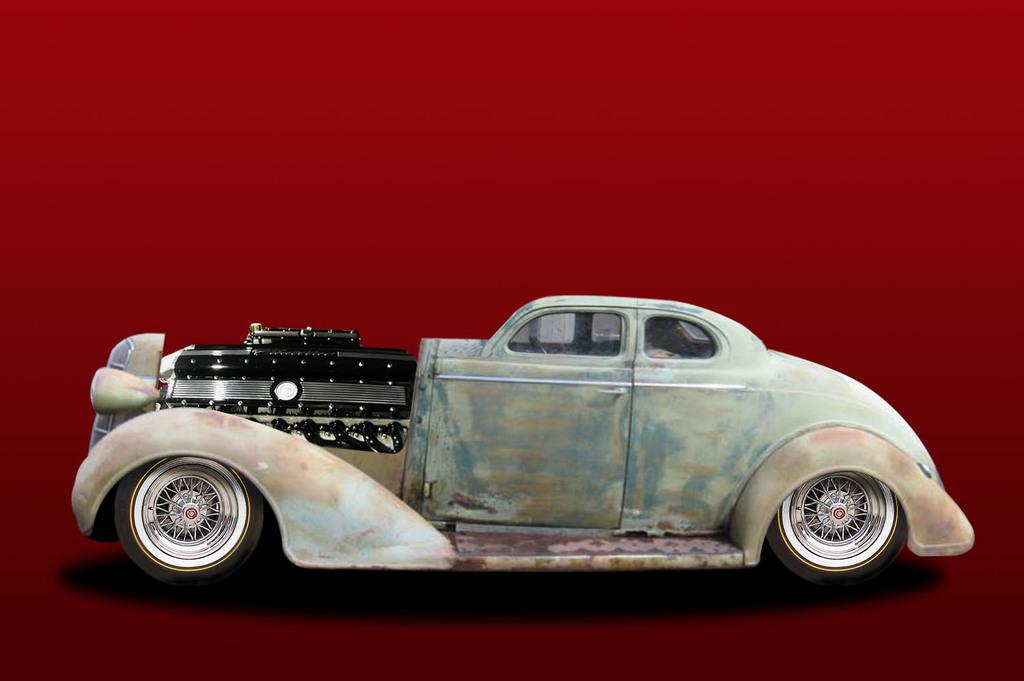What type of vehicle is in the picture? There is a vintage car in the picture. What color is the vintage car? The car is cream in color. What part of the car can be seen in the image? The car's engine is visible in the image. What color is the car's engine? The engine is black in color. What can be seen behind the car in the image? There is a red color surface behind the car. How many cubs are playing with the vintage car in the image? There are no cubs present in the image; it features a vintage car with its engine visible. What type of air is being used to power the vintage car in the image? The image does not show the car in motion or provide any information about its power source, so it is not possible to determine the type of air being used. 